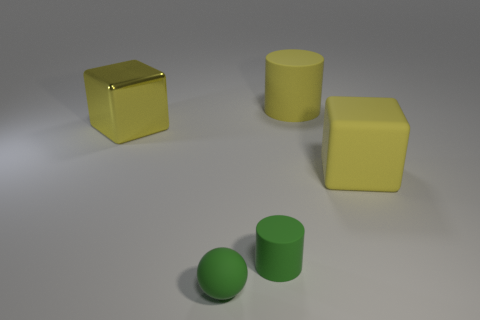Add 2 big purple objects. How many objects exist? 7 Subtract all cylinders. How many objects are left? 3 Add 2 yellow cubes. How many yellow cubes are left? 4 Add 5 yellow cubes. How many yellow cubes exist? 7 Subtract 0 cyan cylinders. How many objects are left? 5 Subtract all green cylinders. Subtract all spheres. How many objects are left? 3 